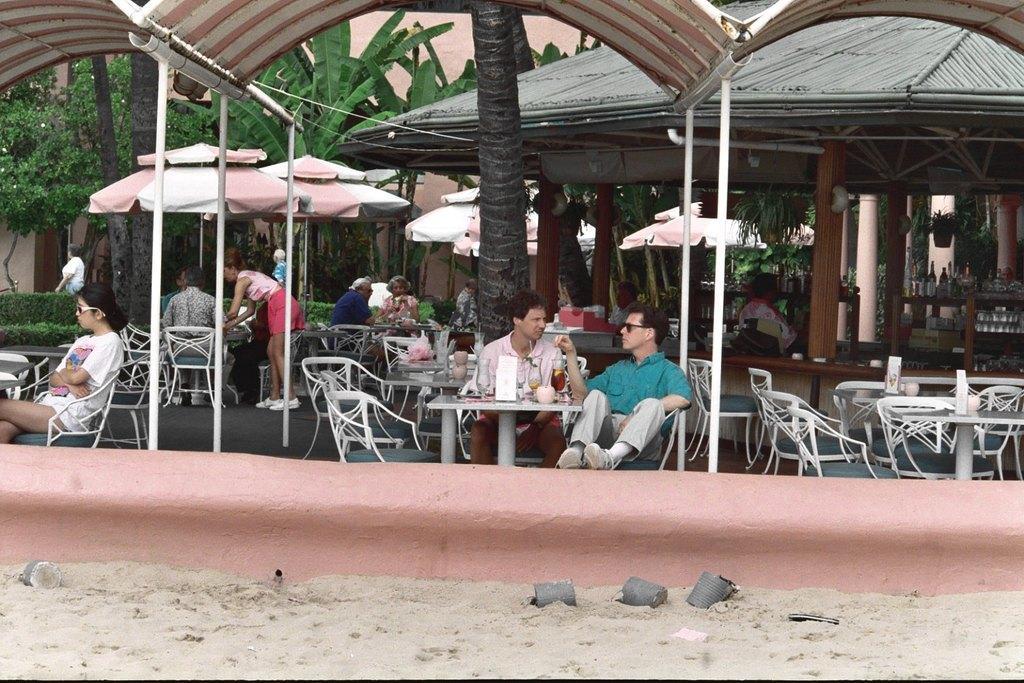Describe this image in one or two sentences. There are two man sitting on a chair around a table. To the left side their is a woman sitting on a chair under a tent. At the background there are few people sitting under an umbrella. To the right side their is hut in which there are bottles,glasses,boxes and a pillar. In the background there is tree and a wall. At the bottom there is a sand. 